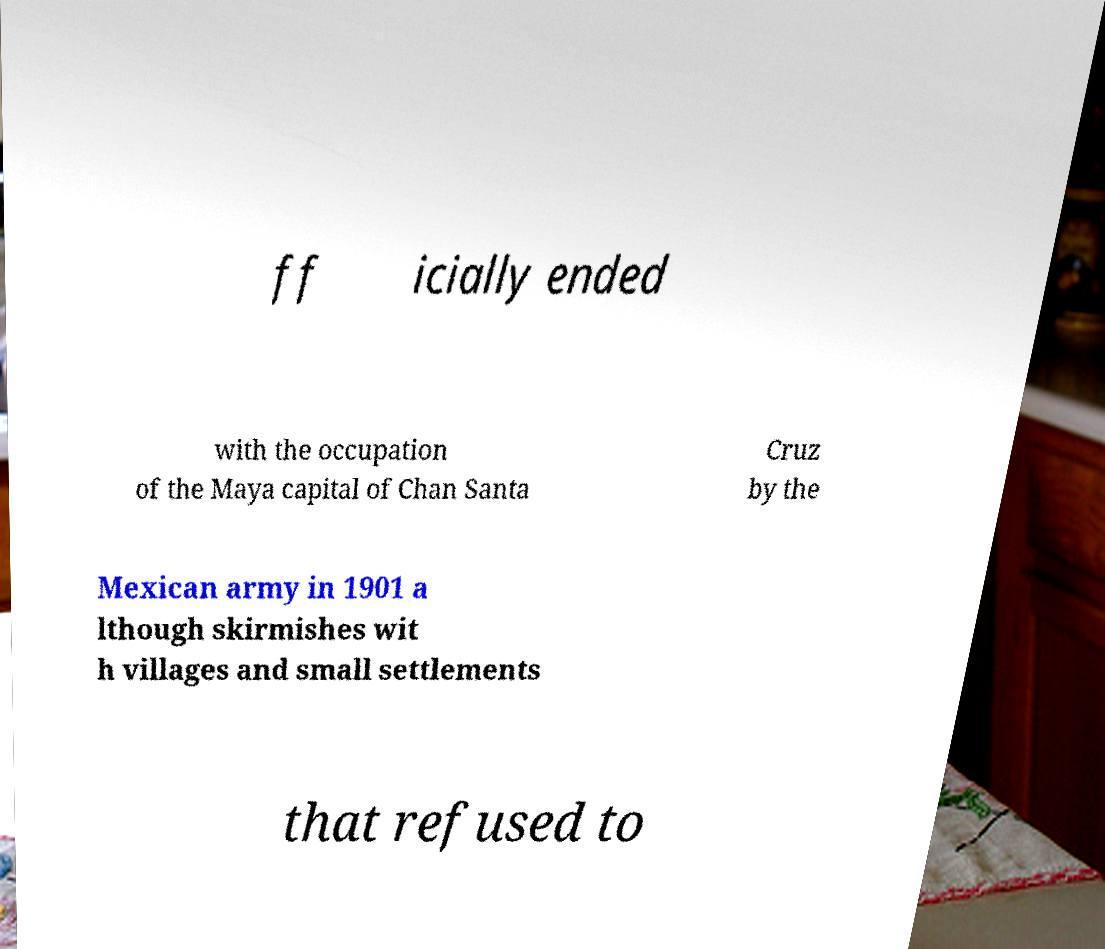Could you assist in decoding the text presented in this image and type it out clearly? ff icially ended with the occupation of the Maya capital of Chan Santa Cruz by the Mexican army in 1901 a lthough skirmishes wit h villages and small settlements that refused to 